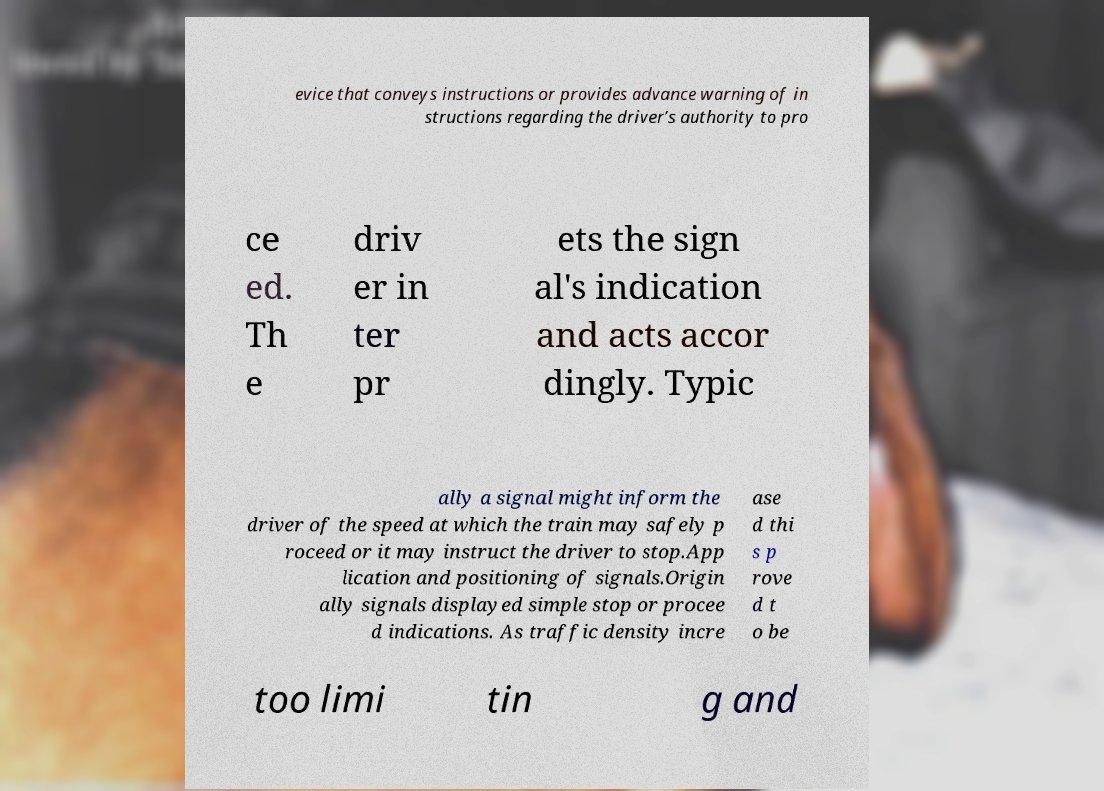I need the written content from this picture converted into text. Can you do that? evice that conveys instructions or provides advance warning of in structions regarding the driver’s authority to pro ce ed. Th e driv er in ter pr ets the sign al's indication and acts accor dingly. Typic ally a signal might inform the driver of the speed at which the train may safely p roceed or it may instruct the driver to stop.App lication and positioning of signals.Origin ally signals displayed simple stop or procee d indications. As traffic density incre ase d thi s p rove d t o be too limi tin g and 